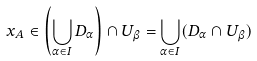<formula> <loc_0><loc_0><loc_500><loc_500>x _ { A } \in \left ( \bigcup _ { \alpha \in I } D _ { \alpha } \right ) \cap U _ { \beta } = \bigcup _ { \alpha \in I } ( D _ { \alpha } \cap U _ { \beta } )</formula> 